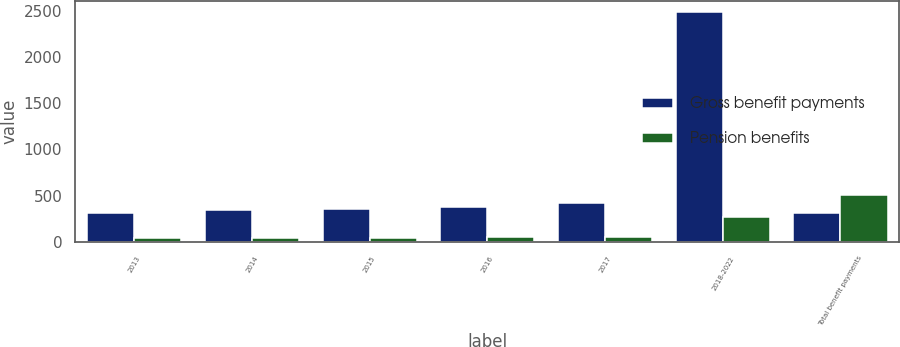<chart> <loc_0><loc_0><loc_500><loc_500><stacked_bar_chart><ecel><fcel>2013<fcel>2014<fcel>2015<fcel>2016<fcel>2017<fcel>2018-2022<fcel>Total benefit payments<nl><fcel>Gross benefit payments<fcel>318<fcel>345<fcel>357<fcel>383<fcel>417<fcel>2483<fcel>318<nl><fcel>Pension benefits<fcel>44<fcel>45<fcel>47<fcel>48<fcel>50<fcel>275<fcel>509<nl></chart> 